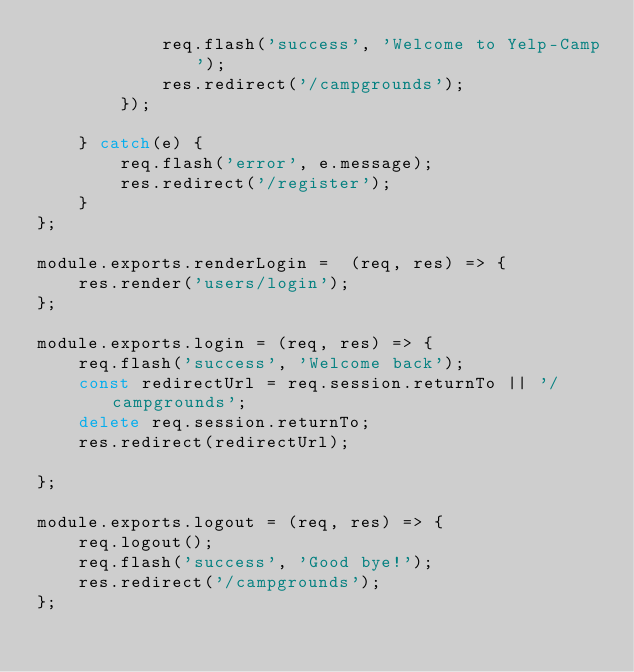<code> <loc_0><loc_0><loc_500><loc_500><_JavaScript_>            req.flash('success', 'Welcome to Yelp-Camp');
            res.redirect('/campgrounds');
        });
        
    } catch(e) {
        req.flash('error', e.message);
        res.redirect('/register');
    }
};

module.exports.renderLogin =  (req, res) => {
    res.render('users/login');
};

module.exports.login = (req, res) => {
    req.flash('success', 'Welcome back');
    const redirectUrl = req.session.returnTo || '/campgrounds';
    delete req.session.returnTo;
    res.redirect(redirectUrl);

};

module.exports.logout = (req, res) => {
    req.logout();
    req.flash('success', 'Good bye!');
    res.redirect('/campgrounds');
};</code> 